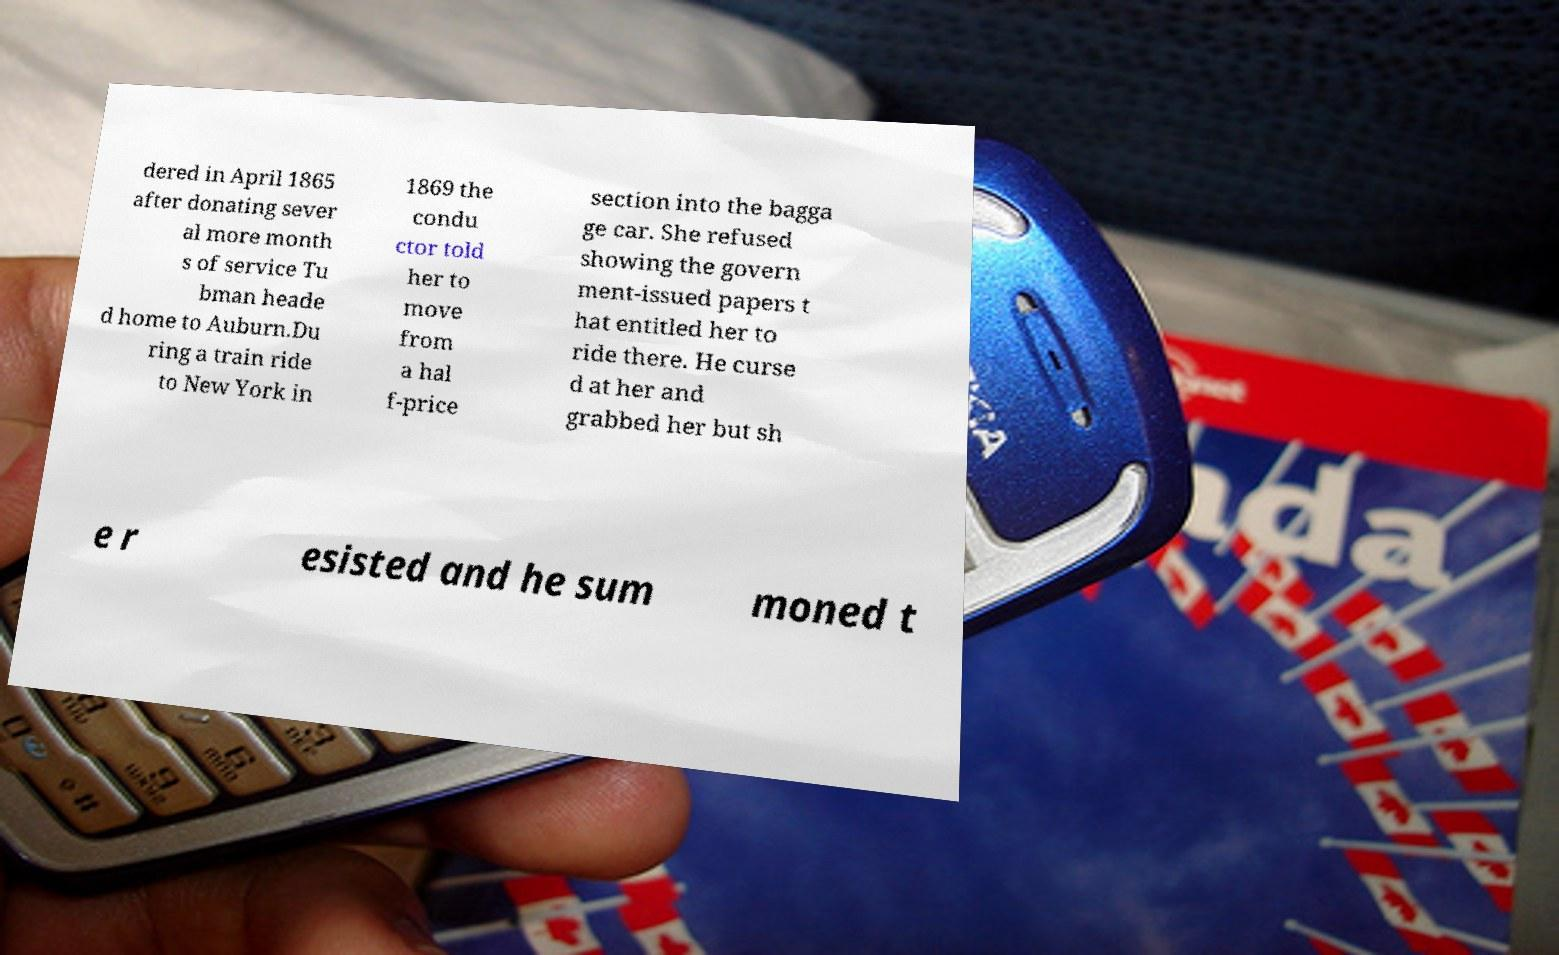Can you accurately transcribe the text from the provided image for me? dered in April 1865 after donating sever al more month s of service Tu bman heade d home to Auburn.Du ring a train ride to New York in 1869 the condu ctor told her to move from a hal f-price section into the bagga ge car. She refused showing the govern ment-issued papers t hat entitled her to ride there. He curse d at her and grabbed her but sh e r esisted and he sum moned t 